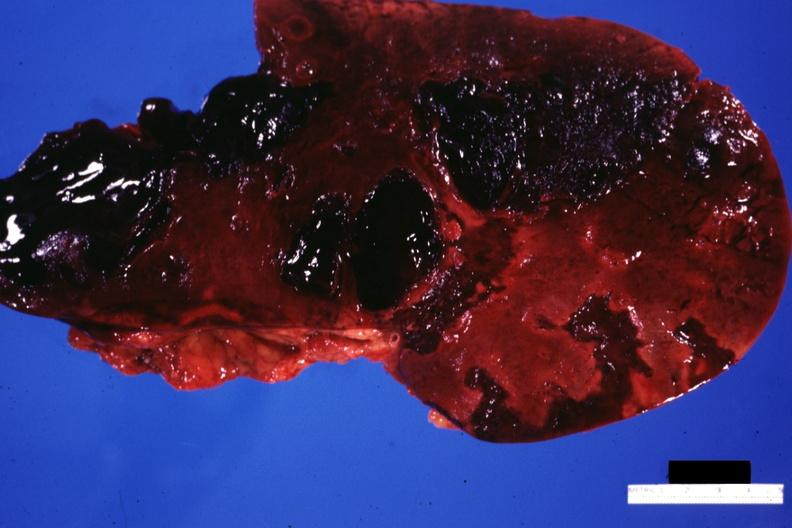what is present?
Answer the question using a single word or phrase. Hepatobiliary 